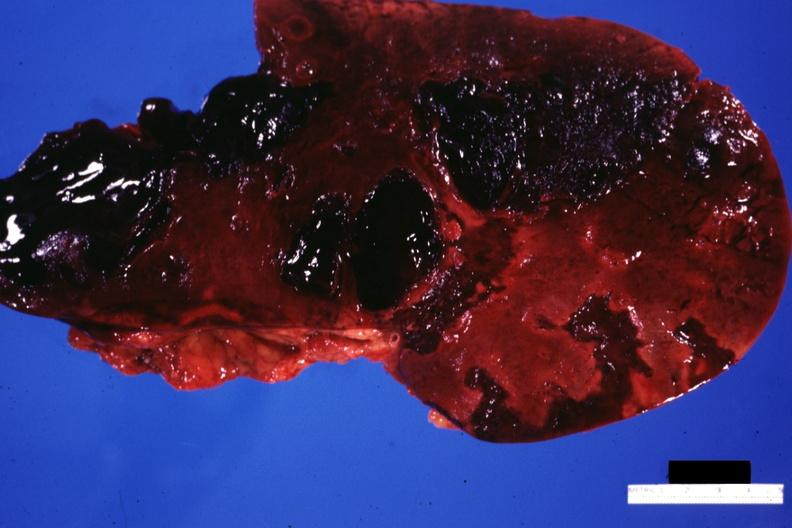what is present?
Answer the question using a single word or phrase. Hepatobiliary 